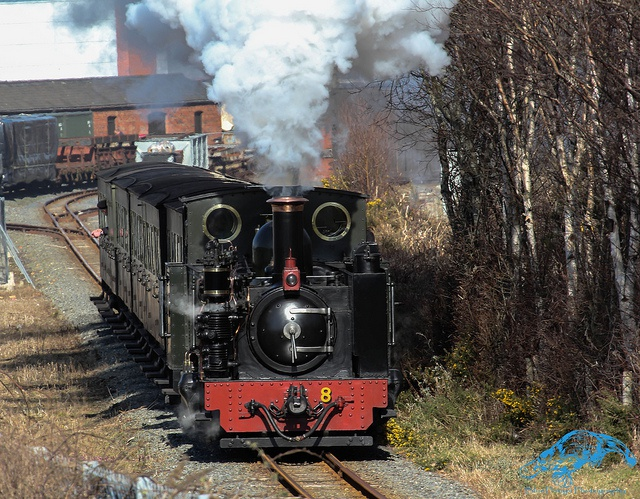Describe the objects in this image and their specific colors. I can see train in gray, black, and brown tones and train in gray, black, and brown tones in this image. 